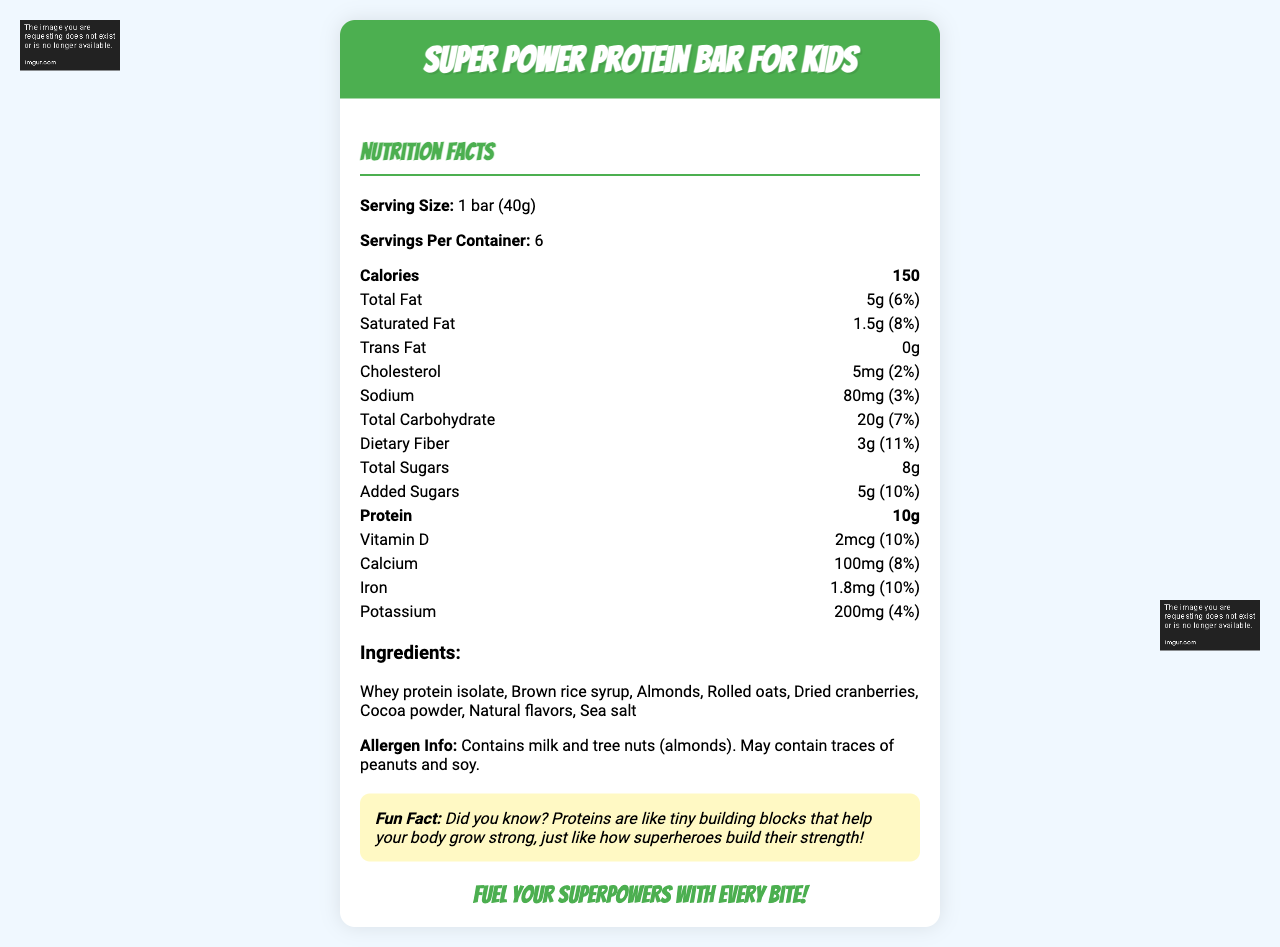what is the serving size? The serving size is listed under the product name: "Serving Size: 1 bar (40g)".
Answer: 1 bar (40g) how many calories are in one serving? The number of calories per serving is directly labeled as 150 in the nutrition facts section.
Answer: 150 what allergens does this product contain? The allergen information states: "Contains milk and tree nuts (almonds)."
Answer: Milk and tree nuts (almonds) what is the percentage of daily value for dietary fiber? The daily value for dietary fiber is listed as 11%.
Answer: 11% name one of the superheroes on the label and describe them One of the superheroes, Captain Protein, is described this way in the document.
Answer: Captain Protein - A muscular superhero with a 'P' emblem on their chest how much protein does each bar have? The amount of protein per bar is labeled as 10g in the nutrition facts section.
Answer: 10g what is the total carbohydrate content per serving? The total carbohydrate content per serving is listed as 20g.
Answer: 20g what is the daily value percentage of calcium in the bar? The daily value percentage for calcium is listed as 8% in the nutrition facts.
Answer: 8% which ingredient is listed first? The list of ingredients starts with "Whey protein isolate."
Answer: Whey protein isolate how many servings are there in one container? It states that there are 6 servings per container.
Answer: 6 how much sodium is in a single bar? The sodium content is listed as 80mg per bar.
Answer: 80mg what's a fun fact about proteins mentioned on the label? The fun fact is stated in the document under the fun fact section.
Answer: Proteins are like tiny building blocks that help your body grow strong, just like how superheroes build their strength! which superhero is at the bottom right corner? A) Captain Protein B) Energy Girl C) Muscle Man The label states that Energy Girl is at the bottom right corner.
Answer: B) Energy Girl how much added sugar is in each bar? The amount of added sugar per bar is listed as 5g.
Answer: 5g what’s the product slogan? The product slogan is included at the end of the document.
Answer: Fuel your superpowers with every bite! does the bar contain any trans fat? The nutrition facts indicate that the trans fat content is 0g.
Answer: No summarize the main nutritional benefits of the bar The main nutritional benefits include a high protein content of 10g, significant dietary fiber (11% DV), and essential vitamins and minerals.
Answer: Provides 10g of protein, 11% DV dietary fiber, and contains essential vitamins and minerals such as Vitamin D, Calcium, and Iron. how many calories come from fats? The label indicates total calories and fat content but does not directly provide the breakdown of calories from fats.
Answer: Not enough information 